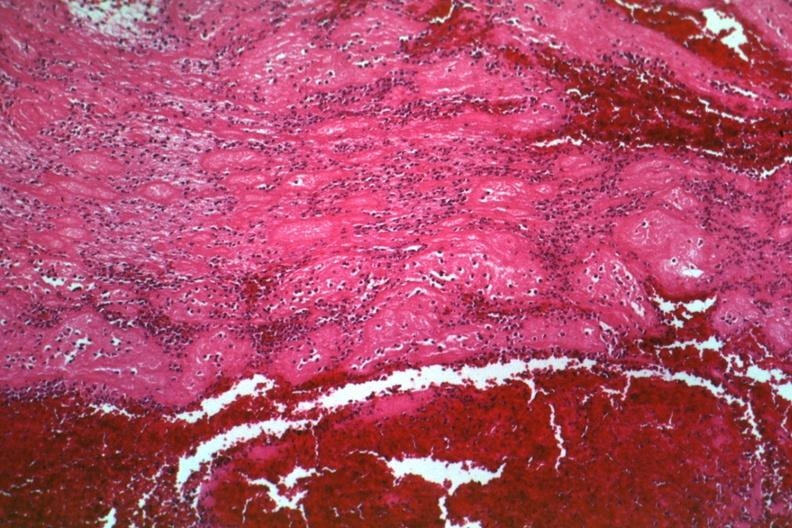s cervical leiomyoma present?
Answer the question using a single word or phrase. No 